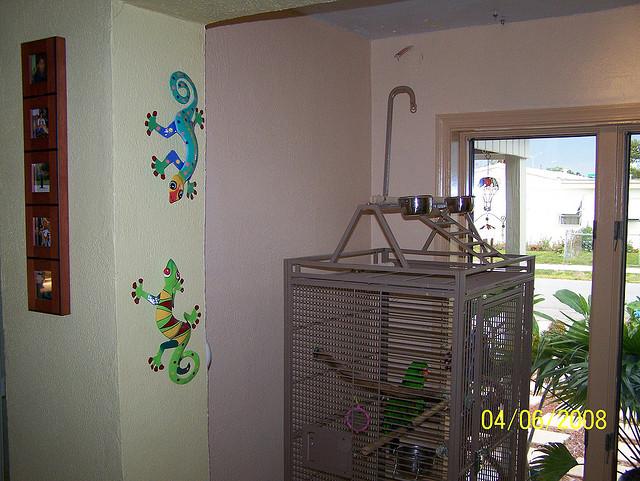What objects are hanging from the ceiling?
Quick response, please. Bird cage. What is outside the door?
Keep it brief. Plants. What kind of animals are on the wall?
Keep it brief. Lizards. What animal is in the cage?
Write a very short answer. Bird. 